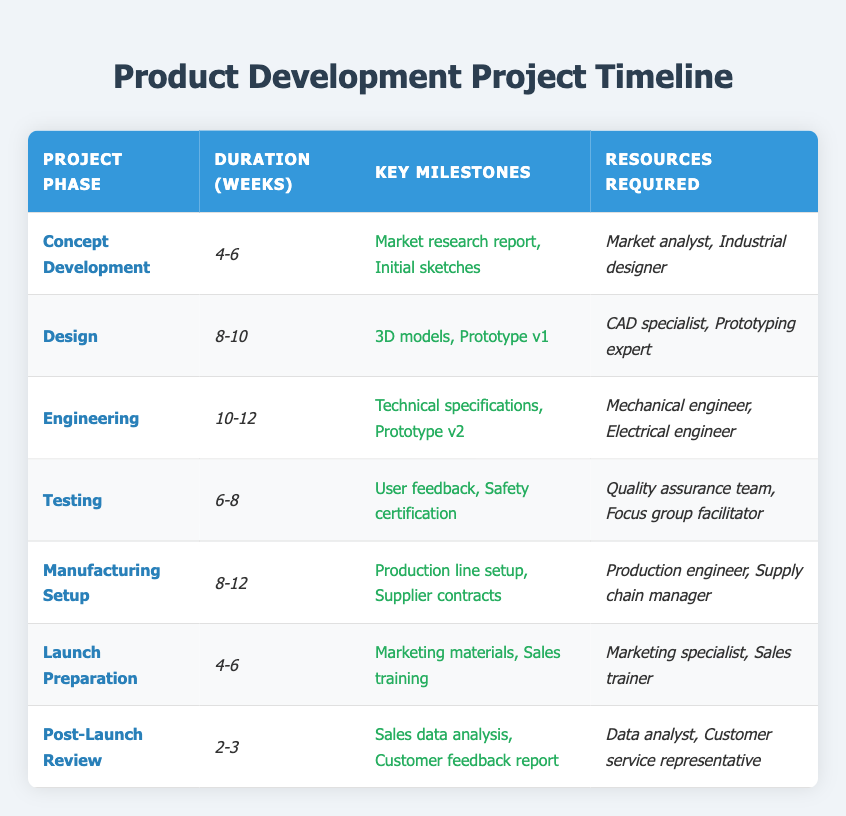What is the duration for the Design phase? The Design phase is listed in the table under the "Duration (Weeks)" column, which shows the value as "8-10".
Answer: 8-10 How many resources are required for the Engineering phase? The Engineering phase lists two resources in the "Resources Required" column: "Mechanical engineer" and "Electrical engineer". Therefore, there are 2 resources required.
Answer: 2 Is the Launch Preparation phase longer than the Testing phase? The Launch Preparation phase has a duration of "4-6" weeks, while the Testing phase has a duration of "6-8" weeks. Since "6" is greater than "4", the Launch Preparation phase is not longer than the Testing phase.
Answer: No What is the total range of weeks for the Engineering and Manufacturing Setup phases combined? For Engineering, the duration is "10-12" weeks and for Manufacturing Setup, it is "8-12" weeks. The minimum combined duration is 10 + 8 = 18 weeks and the maximum is 12 + 12 = 24 weeks. Therefore, the total duration range is "18-24" weeks.
Answer: 18-24 Which project phase requires a Quality Assurance team? By looking at the table, the Testing phase is the only one that mentions "Quality assurance team" in the "Resources Required" column.
Answer: Testing In which phases are Marketing specialists required? The table indicates that Marketing specialists are required in the Launch Preparation phase, as listed in the "Resources Required" column. No other phases mention this resource.
Answer: Launch Preparation What is the average duration across all project phases? To find the average, we sum the values of the duration ranges for each phase: (5 + 8 + 11 + 7 + 10 + 5 + 2.5) = 48.5 weeks total; there are 7 phases, so the average is 48.5 / 7 = approximately 6.93 weeks per phase.
Answer: 6.93 Is there a phase that lasts only 2-3 weeks? The duration values are examined, and the Post-Launch Review phase shows a duration of "2-3" weeks, confirming that there is such a phase.
Answer: Yes What are the two key milestones for the Concept Development phase? In the table, the Concept Development phase lists "Market research report" and "Initial sketches" as its key milestones under the "Key Milestones" column.
Answer: Market research report, Initial sketches 